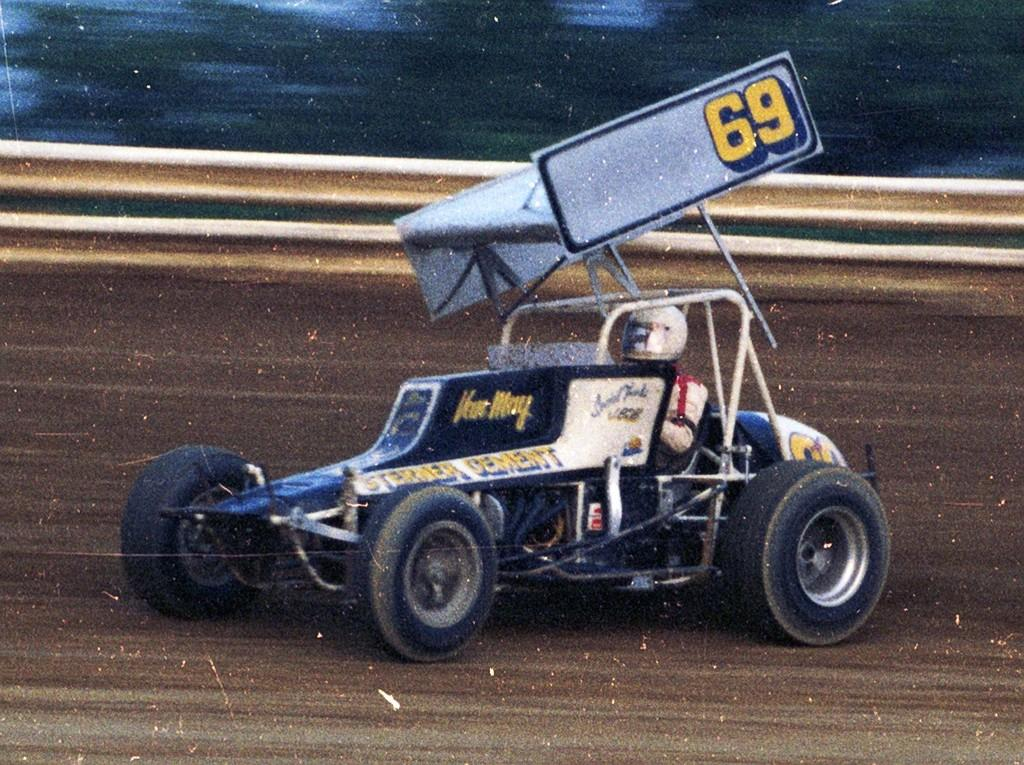<image>
Present a compact description of the photo's key features. A race car is on a dirt track and has the number 69 on it. 